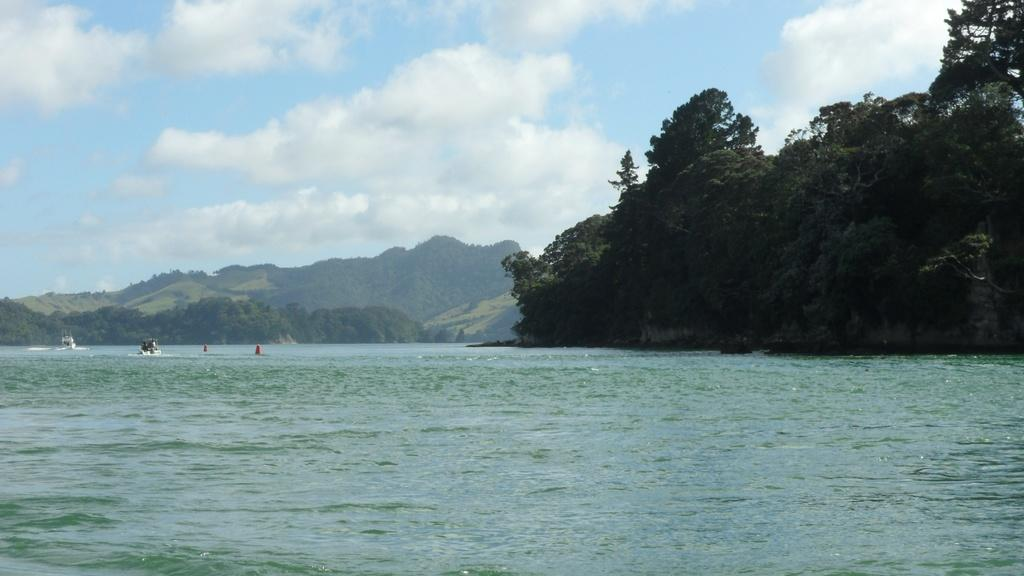What type of vehicles can be seen on the water in the image? There are boats on the water in the image. What type of vegetation is visible in the image? There are trees visible in the image. What type of geographical feature can be seen in the image? There are mountains in the image. What is visible in the background of the image? The sky is visible in the background of the image. What can be seen in the sky in the image? Clouds are present in the sky. How many light bulbs are hanging from the trees in the image? There are no light bulbs present in the image; it features boats on the water, trees, mountains, and clouds in the sky. What type of joke is being told by the mountains in the image? There is no joke being told by the mountains in the image; they are a geographical feature and not capable of telling jokes. 